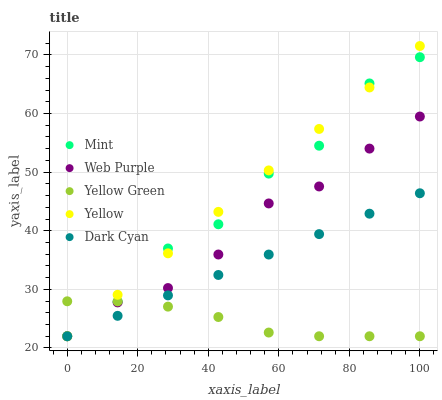Does Yellow Green have the minimum area under the curve?
Answer yes or no. Yes. Does Yellow have the maximum area under the curve?
Answer yes or no. Yes. Does Web Purple have the minimum area under the curve?
Answer yes or no. No. Does Web Purple have the maximum area under the curve?
Answer yes or no. No. Is Yellow the smoothest?
Answer yes or no. Yes. Is Mint the roughest?
Answer yes or no. Yes. Is Web Purple the smoothest?
Answer yes or no. No. Is Web Purple the roughest?
Answer yes or no. No. Does Dark Cyan have the lowest value?
Answer yes or no. Yes. Does Yellow have the highest value?
Answer yes or no. Yes. Does Web Purple have the highest value?
Answer yes or no. No. Does Dark Cyan intersect Web Purple?
Answer yes or no. Yes. Is Dark Cyan less than Web Purple?
Answer yes or no. No. Is Dark Cyan greater than Web Purple?
Answer yes or no. No. 